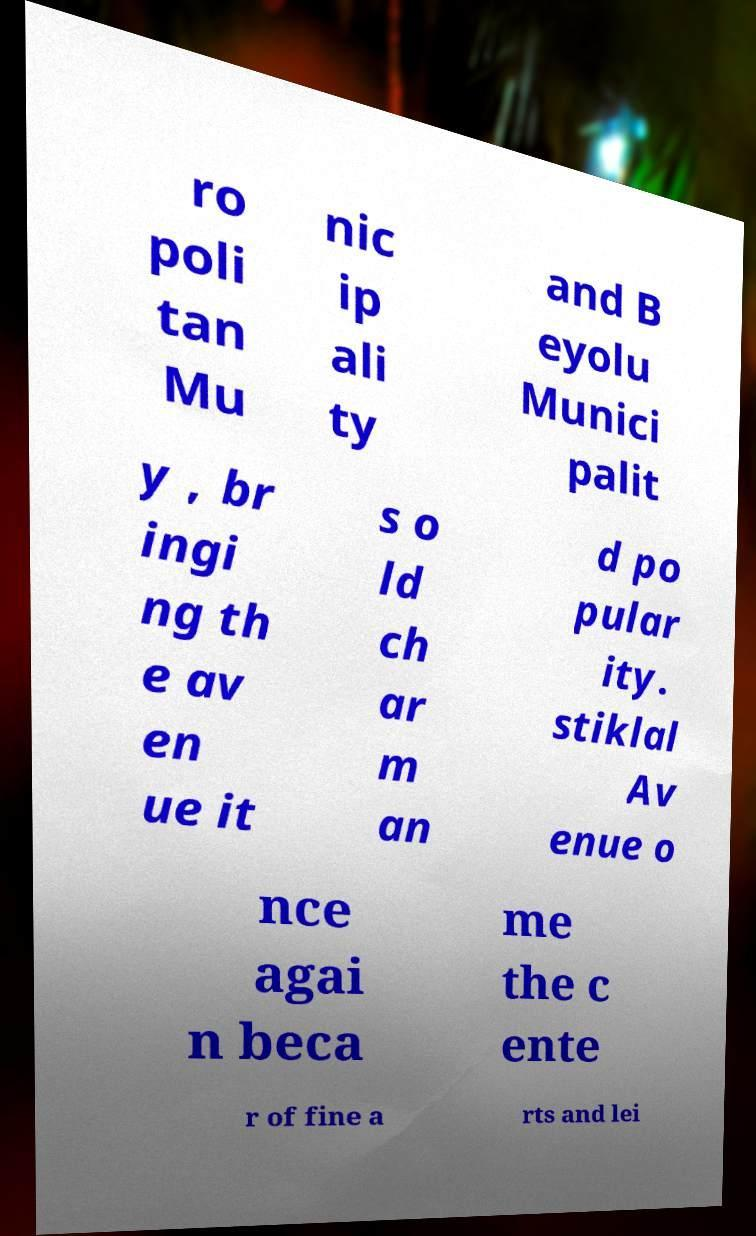Could you extract and type out the text from this image? ro poli tan Mu nic ip ali ty and B eyolu Munici palit y , br ingi ng th e av en ue it s o ld ch ar m an d po pular ity. stiklal Av enue o nce agai n beca me the c ente r of fine a rts and lei 